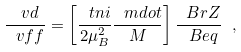Convert formula to latex. <formula><loc_0><loc_0><loc_500><loc_500>\frac { \ v d } { \ v f f } = \left [ \frac { \ t n i } { 2 \mu _ { B } ^ { 2 } } \frac { \ m d o t } { M } \right ] \frac { \ B r Z } { \ B e q } \ ,</formula> 